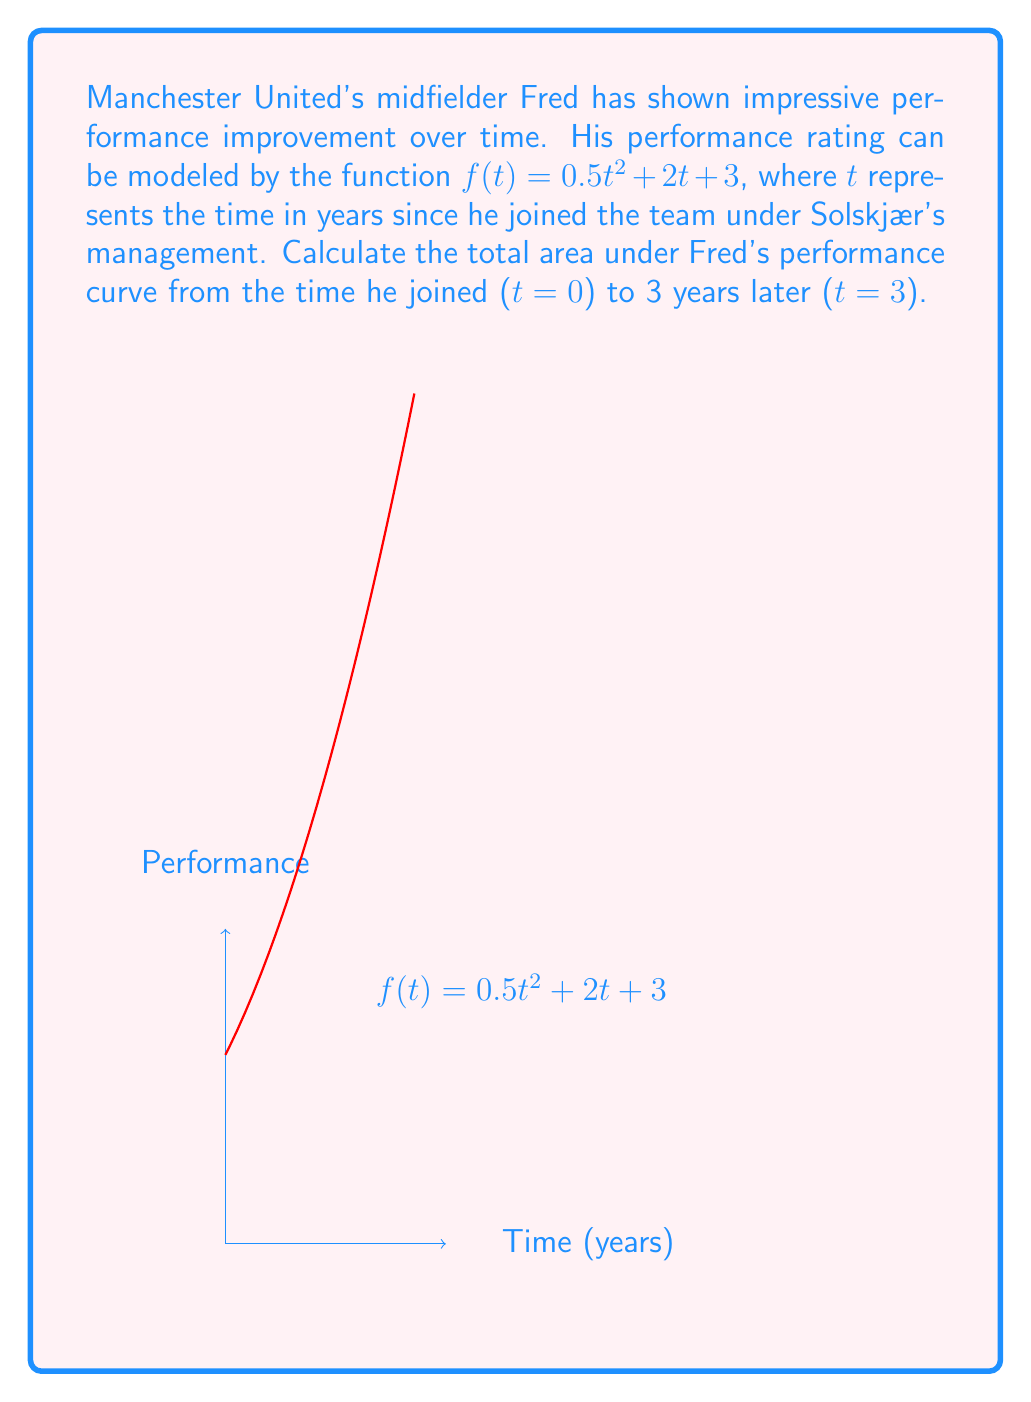Help me with this question. To find the area under the curve, we need to integrate the function $f(t) = 0.5t^2 + 2t + 3$ from $t=0$ to $t=3$. Let's follow these steps:

1) Set up the definite integral:
   $$\int_0^3 (0.5t^2 + 2t + 3) dt$$

2) Integrate each term:
   - For $0.5t^2$: $\int 0.5t^2 dt = \frac{1}{6}t^3$
   - For $2t$: $\int 2t dt = t^2$
   - For $3$: $\int 3 dt = 3t$

3) Apply the fundamental theorem of calculus:
   $$\left[\frac{1}{6}t^3 + t^2 + 3t\right]_0^3$$

4) Evaluate the expression at $t=3$ and $t=0$:
   $$\left(\frac{1}{6}(3^3) + 3^2 + 3(3)\right) - \left(\frac{1}{6}(0^3) + 0^2 + 3(0)\right)$$

5) Simplify:
   $$\left(\frac{27}{6} + 9 + 9\right) - (0)$$
   $$= \frac{27}{6} + 18$$
   $$= \frac{27}{6} + \frac{108}{6}$$
   $$= \frac{135}{6}$$
   $$= 22.5$$

Therefore, the total area under Fred's performance curve from $t=0$ to $t=3$ is 22.5 units.
Answer: 22.5 units 